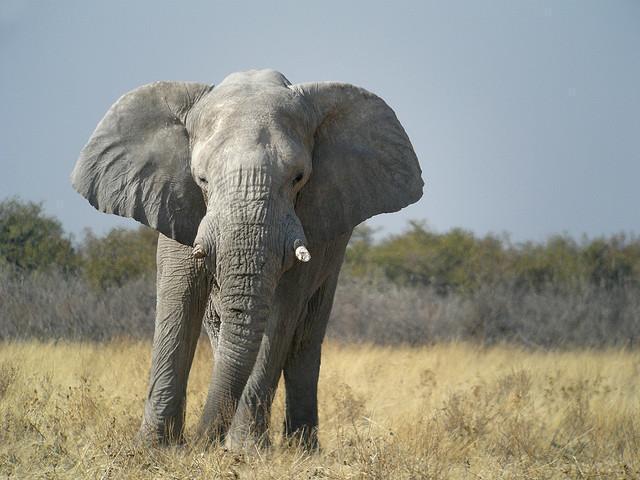How many watches is this man wearing?
Give a very brief answer. 0. 